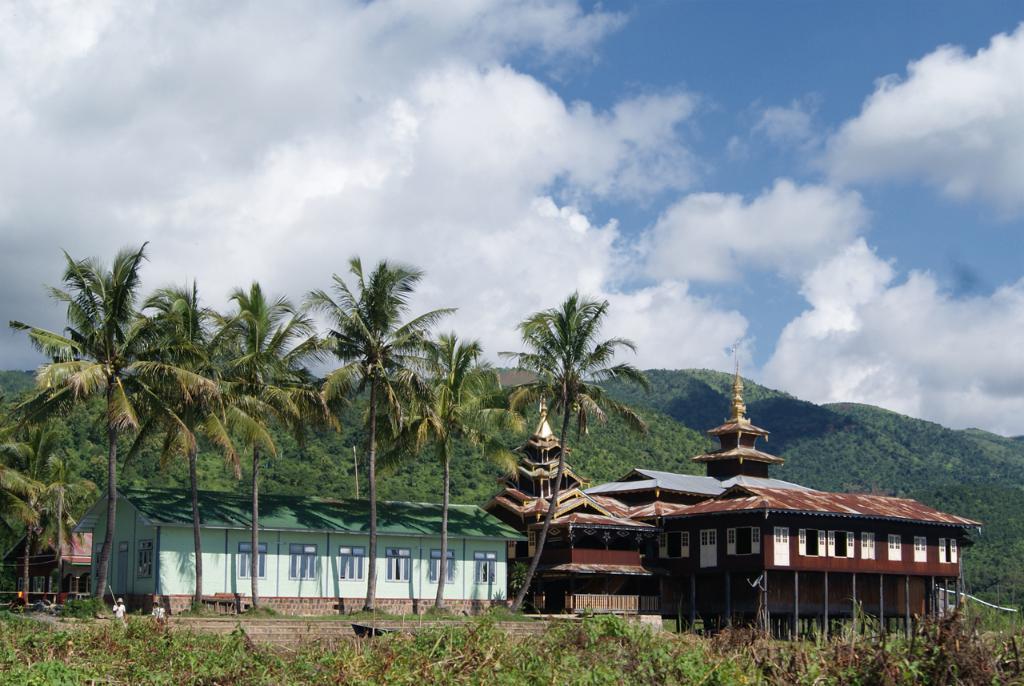Could you give a brief overview of what you see in this image? In this image, we can see Chinese architecture and shed. There are some trees and hills in the middle of the image. There are some plants at the bottom of the image. There are clouds in the sky. 